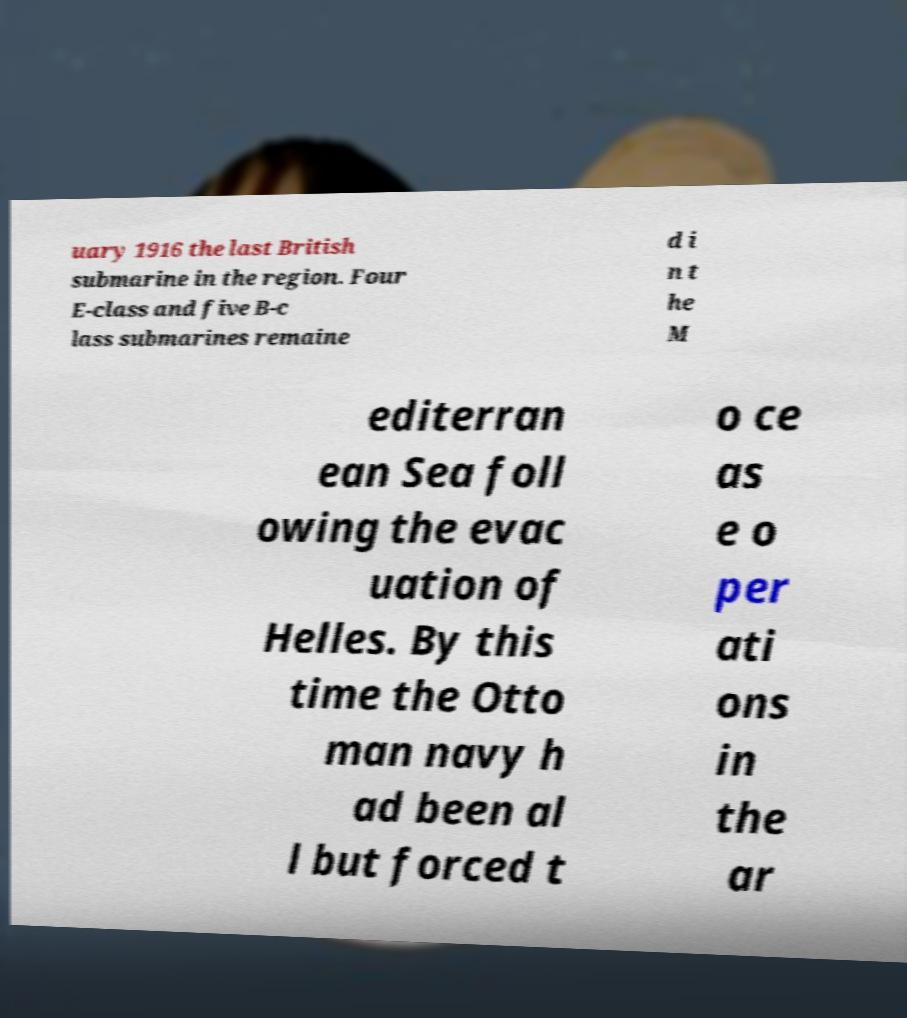I need the written content from this picture converted into text. Can you do that? uary 1916 the last British submarine in the region. Four E-class and five B-c lass submarines remaine d i n t he M editerran ean Sea foll owing the evac uation of Helles. By this time the Otto man navy h ad been al l but forced t o ce as e o per ati ons in the ar 